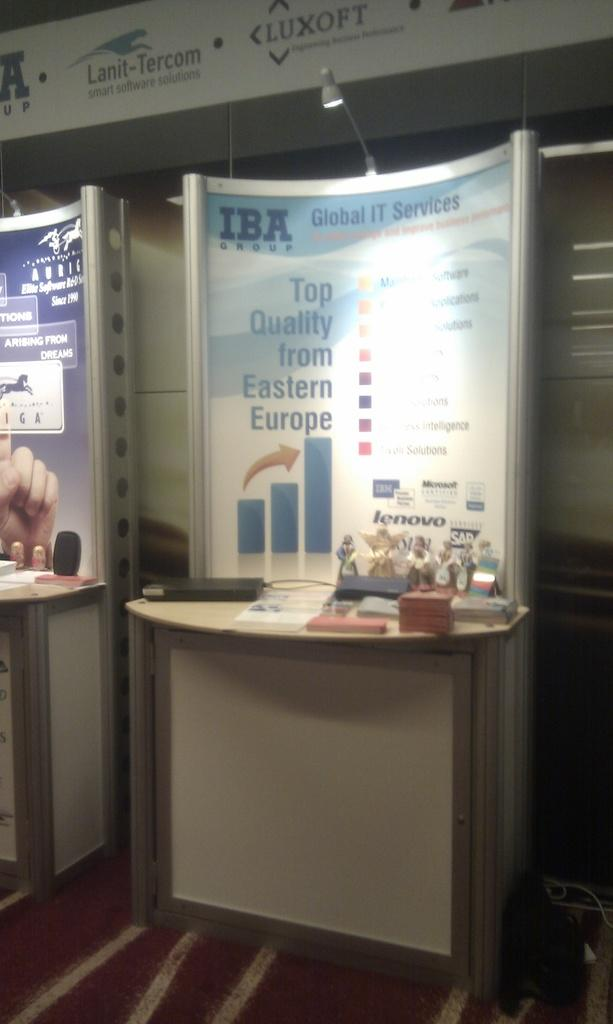What type of furniture is present in the image? There are tables in the image. What is placed on the tables? There are objects on the tables. What else can be seen in the image besides tables? There are boards in the image. What is written on the boards? There is writing on the boards. How is the writing on the boards visible? There is light on the boards. What type of notebook is used to write on the boards in the image? There is no notebook present in the image; the writing is done directly on the boards. 